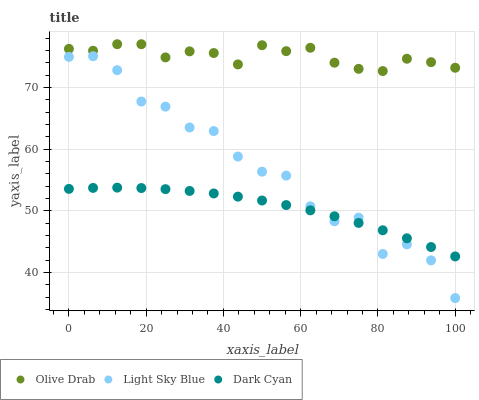Does Dark Cyan have the minimum area under the curve?
Answer yes or no. Yes. Does Olive Drab have the maximum area under the curve?
Answer yes or no. Yes. Does Light Sky Blue have the minimum area under the curve?
Answer yes or no. No. Does Light Sky Blue have the maximum area under the curve?
Answer yes or no. No. Is Dark Cyan the smoothest?
Answer yes or no. Yes. Is Light Sky Blue the roughest?
Answer yes or no. Yes. Is Olive Drab the smoothest?
Answer yes or no. No. Is Olive Drab the roughest?
Answer yes or no. No. Does Light Sky Blue have the lowest value?
Answer yes or no. Yes. Does Olive Drab have the lowest value?
Answer yes or no. No. Does Olive Drab have the highest value?
Answer yes or no. Yes. Does Light Sky Blue have the highest value?
Answer yes or no. No. Is Light Sky Blue less than Olive Drab?
Answer yes or no. Yes. Is Olive Drab greater than Dark Cyan?
Answer yes or no. Yes. Does Light Sky Blue intersect Dark Cyan?
Answer yes or no. Yes. Is Light Sky Blue less than Dark Cyan?
Answer yes or no. No. Is Light Sky Blue greater than Dark Cyan?
Answer yes or no. No. Does Light Sky Blue intersect Olive Drab?
Answer yes or no. No. 